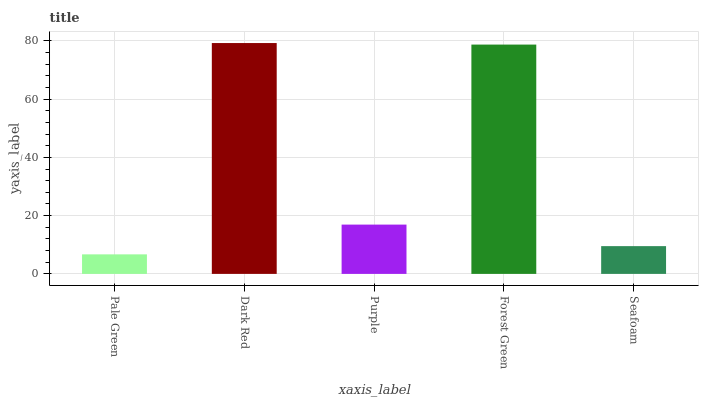Is Pale Green the minimum?
Answer yes or no. Yes. Is Dark Red the maximum?
Answer yes or no. Yes. Is Purple the minimum?
Answer yes or no. No. Is Purple the maximum?
Answer yes or no. No. Is Dark Red greater than Purple?
Answer yes or no. Yes. Is Purple less than Dark Red?
Answer yes or no. Yes. Is Purple greater than Dark Red?
Answer yes or no. No. Is Dark Red less than Purple?
Answer yes or no. No. Is Purple the high median?
Answer yes or no. Yes. Is Purple the low median?
Answer yes or no. Yes. Is Forest Green the high median?
Answer yes or no. No. Is Forest Green the low median?
Answer yes or no. No. 